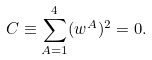Convert formula to latex. <formula><loc_0><loc_0><loc_500><loc_500>C \equiv \sum _ { A = 1 } ^ { 4 } ( w ^ { A } ) ^ { 2 } = 0 .</formula> 